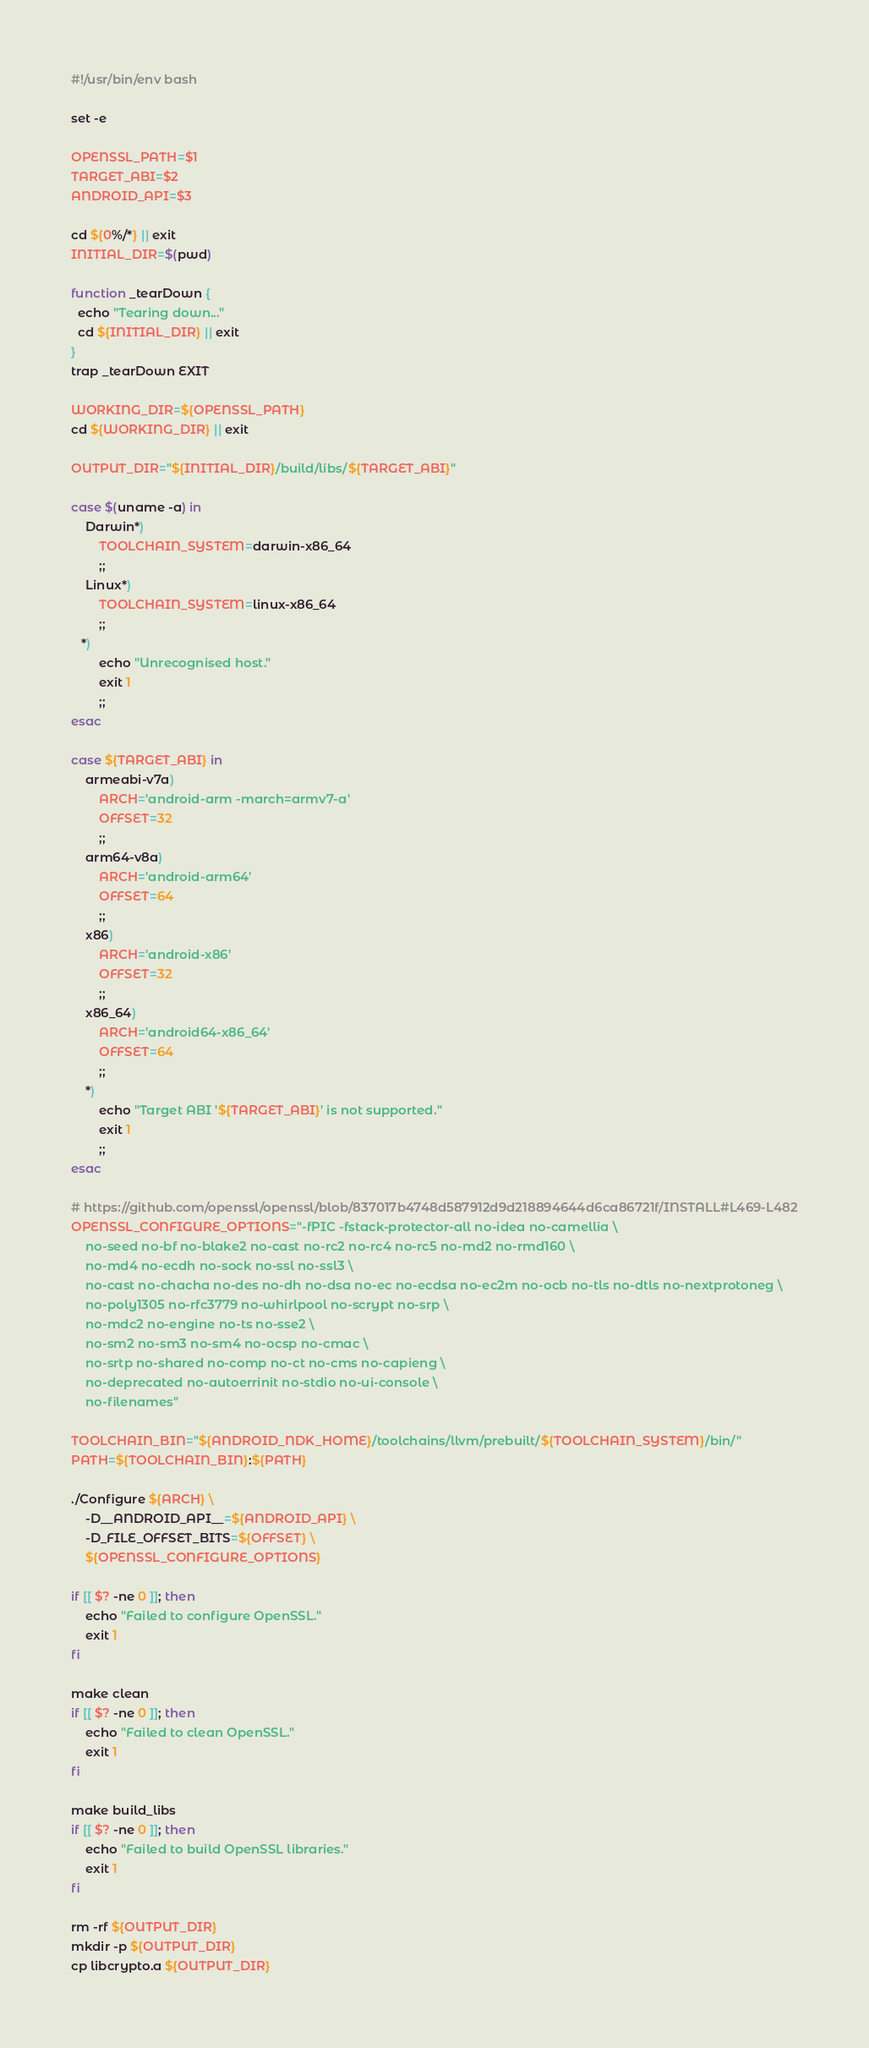<code> <loc_0><loc_0><loc_500><loc_500><_Bash_>#!/usr/bin/env bash

set -e

OPENSSL_PATH=$1
TARGET_ABI=$2
ANDROID_API=$3

cd ${0%/*} || exit
INITIAL_DIR=$(pwd)

function _tearDown {
  echo "Tearing down..."
  cd ${INITIAL_DIR} || exit
}
trap _tearDown EXIT

WORKING_DIR=${OPENSSL_PATH}
cd ${WORKING_DIR} || exit

OUTPUT_DIR="${INITIAL_DIR}/build/libs/${TARGET_ABI}"

case $(uname -a) in
    Darwin*)
        TOOLCHAIN_SYSTEM=darwin-x86_64
        ;;
    Linux*)
        TOOLCHAIN_SYSTEM=linux-x86_64
        ;;
   *)
        echo "Unrecognised host."
        exit 1
        ;;
esac

case ${TARGET_ABI} in
    armeabi-v7a)
        ARCH='android-arm -march=armv7-a'
        OFFSET=32
        ;;
    arm64-v8a)
        ARCH='android-arm64'
        OFFSET=64
        ;;
    x86)
        ARCH='android-x86'
        OFFSET=32
        ;;
    x86_64)
        ARCH='android64-x86_64'
        OFFSET=64
        ;;
    *)
        echo "Target ABI '${TARGET_ABI}' is not supported."
        exit 1
        ;;
esac

# https://github.com/openssl/openssl/blob/837017b4748d587912d9d218894644d6ca86721f/INSTALL#L469-L482
OPENSSL_CONFIGURE_OPTIONS="-fPIC -fstack-protector-all no-idea no-camellia \
    no-seed no-bf no-blake2 no-cast no-rc2 no-rc4 no-rc5 no-md2 no-rmd160 \
    no-md4 no-ecdh no-sock no-ssl no-ssl3 \
    no-cast no-chacha no-des no-dh no-dsa no-ec no-ecdsa no-ec2m no-ocb no-tls no-dtls no-nextprotoneg \
    no-poly1305 no-rfc3779 no-whirlpool no-scrypt no-srp \
    no-mdc2 no-engine no-ts no-sse2 \
    no-sm2 no-sm3 no-sm4 no-ocsp no-cmac \
    no-srtp no-shared no-comp no-ct no-cms no-capieng \
    no-deprecated no-autoerrinit no-stdio no-ui-console \
    no-filenames"

TOOLCHAIN_BIN="${ANDROID_NDK_HOME}/toolchains/llvm/prebuilt/${TOOLCHAIN_SYSTEM}/bin/"
PATH=${TOOLCHAIN_BIN}:${PATH}

./Configure ${ARCH} \
    -D__ANDROID_API__=${ANDROID_API} \
    -D_FILE_OFFSET_BITS=${OFFSET} \
    ${OPENSSL_CONFIGURE_OPTIONS}

if [[ $? -ne 0 ]]; then
    echo "Failed to configure OpenSSL."
    exit 1
fi

make clean
if [[ $? -ne 0 ]]; then
    echo "Failed to clean OpenSSL."
    exit 1
fi

make build_libs
if [[ $? -ne 0 ]]; then
    echo "Failed to build OpenSSL libraries."
    exit 1
fi

rm -rf ${OUTPUT_DIR}
mkdir -p ${OUTPUT_DIR}
cp libcrypto.a ${OUTPUT_DIR}
</code> 